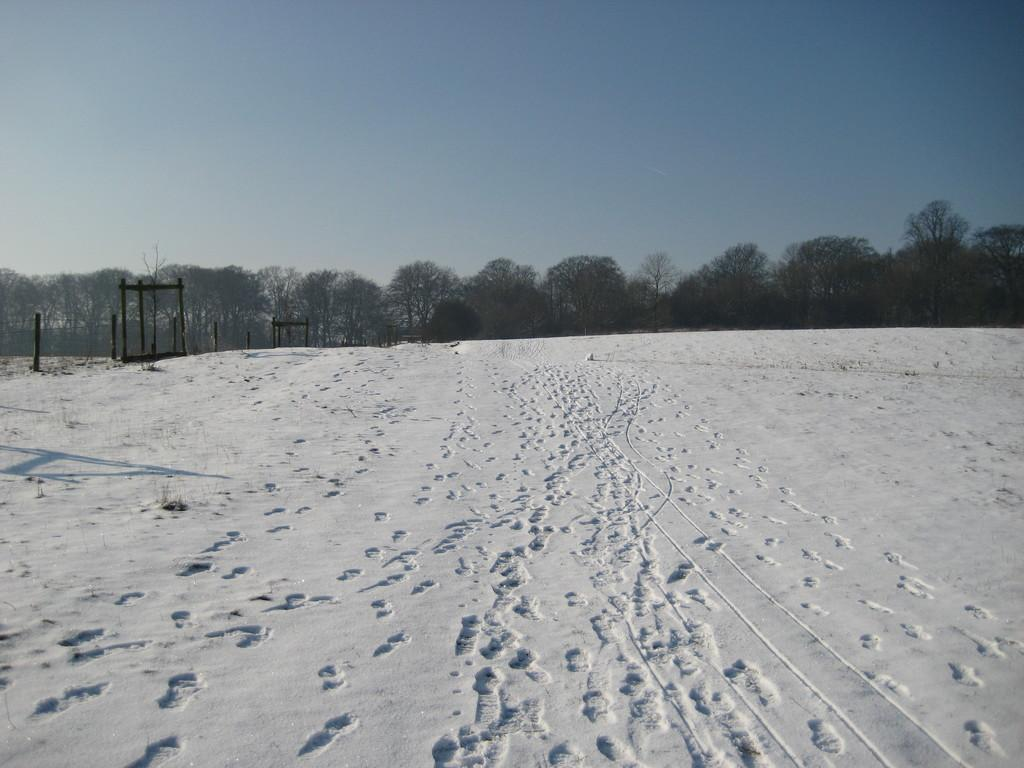What type of weather is depicted in the image? There is snow in the image, indicating a winter scene. What objects can be seen in the image besides the snow? There are poles and trees visible in the image. What is visible in the background of the image? The sky is visible in the background of the image. What type of cakes are being served at the event in the image? There is no event or cakes present in the image; it depicts a snowy scene with poles and trees. 